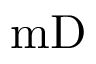Convert formula to latex. <formula><loc_0><loc_0><loc_500><loc_500>m D</formula> 